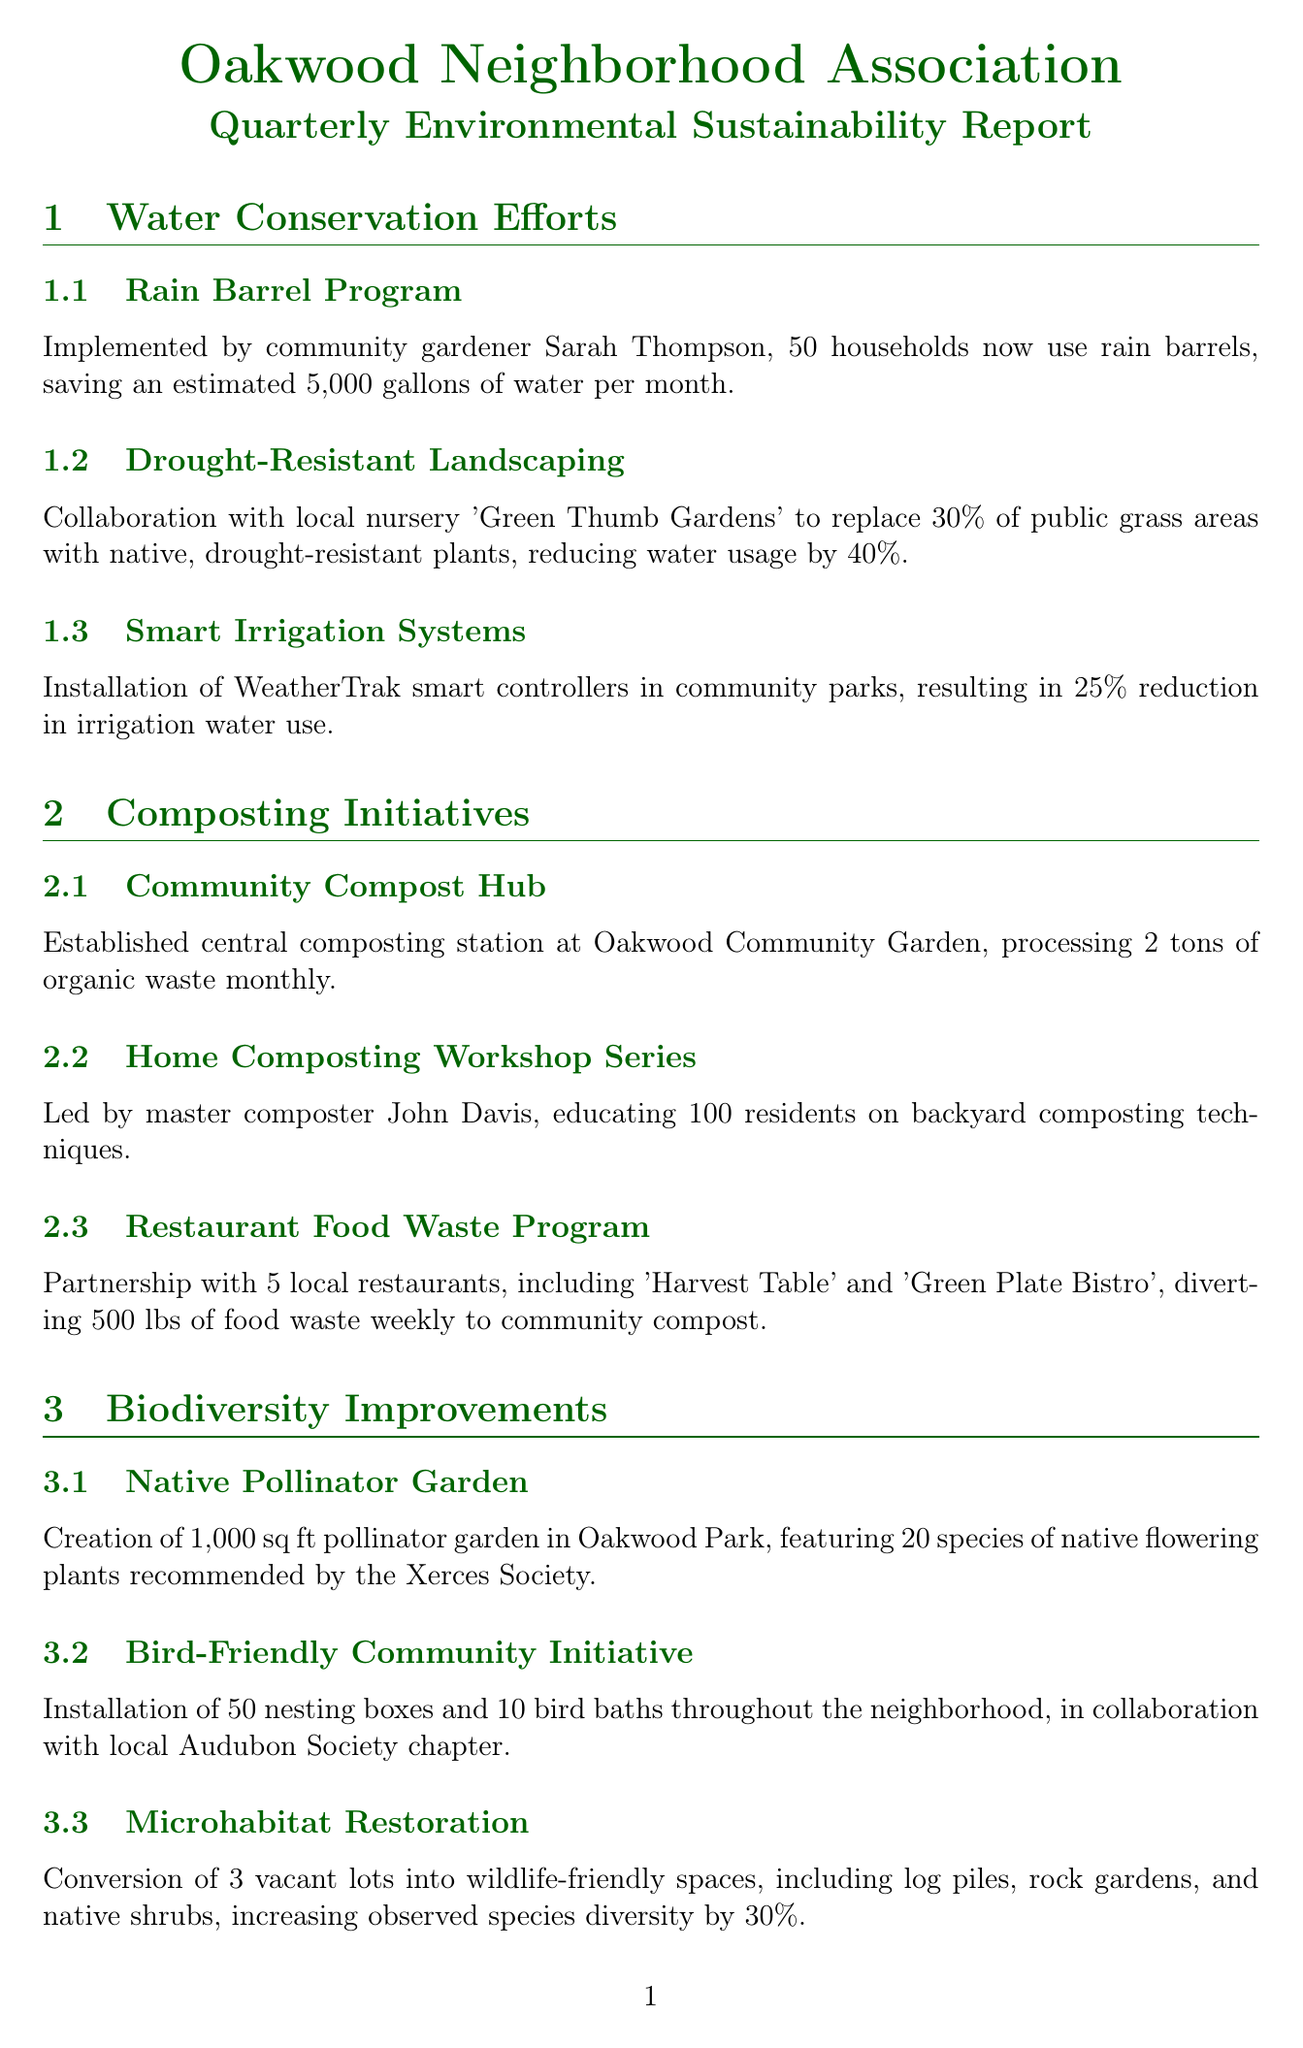What is the title of the report? The title of the report is presented at the top section of the document.
Answer: Oakwood Neighborhood Association Quarterly Environmental Sustainability Report How many households use rain barrels? The number of households using rain barrels is specified in the water conservation section.
Answer: 50 households What is the estimated amount of water saved per month from the rain barrel program? This value is detailed in the rain barrel program subsection.
Answer: 5,000 gallons Who is the master composter mentioned in the document? The name of the master composter is included in the key contributors section.
Answer: John Davis What percentage of public grass areas will be replaced with native plants? The percentage is detailed in the drought-resistant landscaping subsection.
Answer: 30% How many species are featured in the Native Pollinator Garden? The number of species is specified in the biodiversity section regarding the pollinator garden.
Answer: 20 species What is the total amount of waste diverted monthly through the restaurant food waste program? This figure is provided in the composting initiatives section.
Answer: 500 lbs What is the average attendance at the Environmental Education Series workshops? The average attendance is mentioned in the community engagement section.
Answer: 35 residents How many nesting boxes were installed through the Bird-Friendly Community Initiative? The number of nesting boxes is outlined in the biodiversity improvements section.
Answer: 50 nesting boxes 